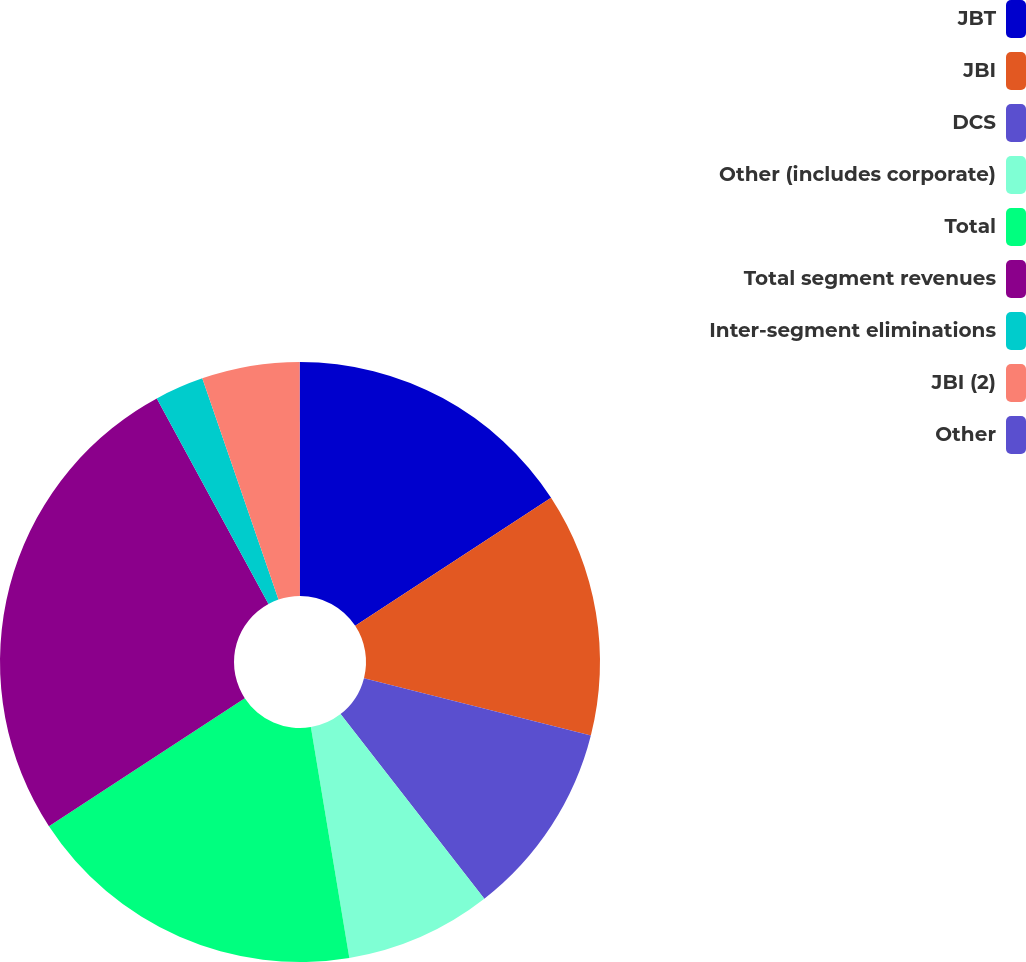Convert chart to OTSL. <chart><loc_0><loc_0><loc_500><loc_500><pie_chart><fcel>JBT<fcel>JBI<fcel>DCS<fcel>Other (includes corporate)<fcel>Total<fcel>Total segment revenues<fcel>Inter-segment eliminations<fcel>JBI (2)<fcel>Other<nl><fcel>15.78%<fcel>13.16%<fcel>10.53%<fcel>7.9%<fcel>18.41%<fcel>26.3%<fcel>2.64%<fcel>5.27%<fcel>0.01%<nl></chart> 